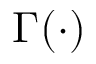<formula> <loc_0><loc_0><loc_500><loc_500>\Gamma ( \cdot )</formula> 